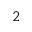Convert formula to latex. <formula><loc_0><loc_0><loc_500><loc_500>2</formula> 